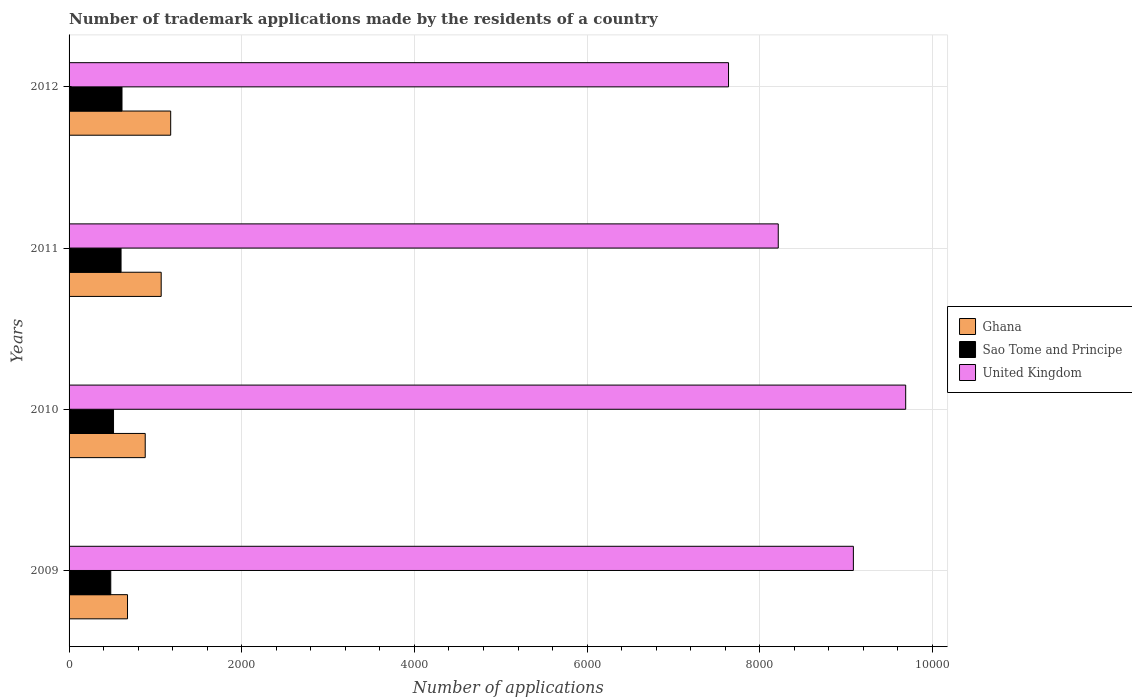How many different coloured bars are there?
Your answer should be very brief. 3. How many groups of bars are there?
Your response must be concise. 4. Are the number of bars on each tick of the Y-axis equal?
Ensure brevity in your answer.  Yes. How many bars are there on the 3rd tick from the top?
Ensure brevity in your answer.  3. What is the number of trademark applications made by the residents in Sao Tome and Principe in 2010?
Ensure brevity in your answer.  515. Across all years, what is the maximum number of trademark applications made by the residents in Ghana?
Make the answer very short. 1177. Across all years, what is the minimum number of trademark applications made by the residents in Sao Tome and Principe?
Provide a succinct answer. 483. In which year was the number of trademark applications made by the residents in United Kingdom minimum?
Offer a terse response. 2012. What is the total number of trademark applications made by the residents in Sao Tome and Principe in the graph?
Keep it short and to the point. 2213. What is the difference between the number of trademark applications made by the residents in Sao Tome and Principe in 2010 and that in 2011?
Ensure brevity in your answer.  -87. What is the difference between the number of trademark applications made by the residents in United Kingdom in 2009 and the number of trademark applications made by the residents in Ghana in 2012?
Offer a very short reply. 7907. What is the average number of trademark applications made by the residents in Ghana per year?
Make the answer very short. 950.75. In the year 2010, what is the difference between the number of trademark applications made by the residents in United Kingdom and number of trademark applications made by the residents in Ghana?
Your answer should be compact. 8808. What is the ratio of the number of trademark applications made by the residents in Ghana in 2011 to that in 2012?
Provide a succinct answer. 0.91. Is the number of trademark applications made by the residents in Ghana in 2011 less than that in 2012?
Offer a terse response. Yes. Is the difference between the number of trademark applications made by the residents in United Kingdom in 2009 and 2012 greater than the difference between the number of trademark applications made by the residents in Ghana in 2009 and 2012?
Ensure brevity in your answer.  Yes. What is the difference between the highest and the lowest number of trademark applications made by the residents in Sao Tome and Principe?
Ensure brevity in your answer.  130. In how many years, is the number of trademark applications made by the residents in Sao Tome and Principe greater than the average number of trademark applications made by the residents in Sao Tome and Principe taken over all years?
Give a very brief answer. 2. Is the sum of the number of trademark applications made by the residents in United Kingdom in 2011 and 2012 greater than the maximum number of trademark applications made by the residents in Ghana across all years?
Keep it short and to the point. Yes. What does the 1st bar from the top in 2010 represents?
Provide a succinct answer. United Kingdom. What does the 1st bar from the bottom in 2009 represents?
Keep it short and to the point. Ghana. Is it the case that in every year, the sum of the number of trademark applications made by the residents in Ghana and number of trademark applications made by the residents in Sao Tome and Principe is greater than the number of trademark applications made by the residents in United Kingdom?
Ensure brevity in your answer.  No. How many bars are there?
Provide a short and direct response. 12. How many years are there in the graph?
Your answer should be very brief. 4. What is the difference between two consecutive major ticks on the X-axis?
Ensure brevity in your answer.  2000. How are the legend labels stacked?
Your answer should be very brief. Vertical. What is the title of the graph?
Provide a succinct answer. Number of trademark applications made by the residents of a country. Does "Turkey" appear as one of the legend labels in the graph?
Your answer should be very brief. No. What is the label or title of the X-axis?
Make the answer very short. Number of applications. What is the Number of applications in Ghana in 2009?
Keep it short and to the point. 677. What is the Number of applications in Sao Tome and Principe in 2009?
Provide a succinct answer. 483. What is the Number of applications in United Kingdom in 2009?
Your response must be concise. 9084. What is the Number of applications of Ghana in 2010?
Offer a very short reply. 882. What is the Number of applications of Sao Tome and Principe in 2010?
Provide a short and direct response. 515. What is the Number of applications of United Kingdom in 2010?
Keep it short and to the point. 9690. What is the Number of applications in Ghana in 2011?
Ensure brevity in your answer.  1067. What is the Number of applications in Sao Tome and Principe in 2011?
Offer a terse response. 602. What is the Number of applications in United Kingdom in 2011?
Your response must be concise. 8214. What is the Number of applications in Ghana in 2012?
Give a very brief answer. 1177. What is the Number of applications of Sao Tome and Principe in 2012?
Keep it short and to the point. 613. What is the Number of applications of United Kingdom in 2012?
Offer a terse response. 7638. Across all years, what is the maximum Number of applications in Ghana?
Keep it short and to the point. 1177. Across all years, what is the maximum Number of applications of Sao Tome and Principe?
Give a very brief answer. 613. Across all years, what is the maximum Number of applications in United Kingdom?
Give a very brief answer. 9690. Across all years, what is the minimum Number of applications of Ghana?
Provide a short and direct response. 677. Across all years, what is the minimum Number of applications of Sao Tome and Principe?
Provide a succinct answer. 483. Across all years, what is the minimum Number of applications in United Kingdom?
Make the answer very short. 7638. What is the total Number of applications of Ghana in the graph?
Your answer should be compact. 3803. What is the total Number of applications of Sao Tome and Principe in the graph?
Provide a short and direct response. 2213. What is the total Number of applications of United Kingdom in the graph?
Provide a succinct answer. 3.46e+04. What is the difference between the Number of applications of Ghana in 2009 and that in 2010?
Keep it short and to the point. -205. What is the difference between the Number of applications in Sao Tome and Principe in 2009 and that in 2010?
Keep it short and to the point. -32. What is the difference between the Number of applications in United Kingdom in 2009 and that in 2010?
Make the answer very short. -606. What is the difference between the Number of applications of Ghana in 2009 and that in 2011?
Provide a succinct answer. -390. What is the difference between the Number of applications in Sao Tome and Principe in 2009 and that in 2011?
Keep it short and to the point. -119. What is the difference between the Number of applications in United Kingdom in 2009 and that in 2011?
Your response must be concise. 870. What is the difference between the Number of applications in Ghana in 2009 and that in 2012?
Your answer should be very brief. -500. What is the difference between the Number of applications in Sao Tome and Principe in 2009 and that in 2012?
Give a very brief answer. -130. What is the difference between the Number of applications in United Kingdom in 2009 and that in 2012?
Your answer should be compact. 1446. What is the difference between the Number of applications of Ghana in 2010 and that in 2011?
Your answer should be very brief. -185. What is the difference between the Number of applications of Sao Tome and Principe in 2010 and that in 2011?
Offer a very short reply. -87. What is the difference between the Number of applications of United Kingdom in 2010 and that in 2011?
Provide a succinct answer. 1476. What is the difference between the Number of applications in Ghana in 2010 and that in 2012?
Offer a very short reply. -295. What is the difference between the Number of applications in Sao Tome and Principe in 2010 and that in 2012?
Make the answer very short. -98. What is the difference between the Number of applications in United Kingdom in 2010 and that in 2012?
Give a very brief answer. 2052. What is the difference between the Number of applications in Ghana in 2011 and that in 2012?
Give a very brief answer. -110. What is the difference between the Number of applications in United Kingdom in 2011 and that in 2012?
Provide a short and direct response. 576. What is the difference between the Number of applications in Ghana in 2009 and the Number of applications in Sao Tome and Principe in 2010?
Keep it short and to the point. 162. What is the difference between the Number of applications in Ghana in 2009 and the Number of applications in United Kingdom in 2010?
Offer a very short reply. -9013. What is the difference between the Number of applications of Sao Tome and Principe in 2009 and the Number of applications of United Kingdom in 2010?
Offer a very short reply. -9207. What is the difference between the Number of applications in Ghana in 2009 and the Number of applications in Sao Tome and Principe in 2011?
Provide a succinct answer. 75. What is the difference between the Number of applications of Ghana in 2009 and the Number of applications of United Kingdom in 2011?
Give a very brief answer. -7537. What is the difference between the Number of applications in Sao Tome and Principe in 2009 and the Number of applications in United Kingdom in 2011?
Your answer should be very brief. -7731. What is the difference between the Number of applications of Ghana in 2009 and the Number of applications of Sao Tome and Principe in 2012?
Offer a terse response. 64. What is the difference between the Number of applications in Ghana in 2009 and the Number of applications in United Kingdom in 2012?
Make the answer very short. -6961. What is the difference between the Number of applications in Sao Tome and Principe in 2009 and the Number of applications in United Kingdom in 2012?
Your response must be concise. -7155. What is the difference between the Number of applications in Ghana in 2010 and the Number of applications in Sao Tome and Principe in 2011?
Ensure brevity in your answer.  280. What is the difference between the Number of applications in Ghana in 2010 and the Number of applications in United Kingdom in 2011?
Give a very brief answer. -7332. What is the difference between the Number of applications of Sao Tome and Principe in 2010 and the Number of applications of United Kingdom in 2011?
Your answer should be very brief. -7699. What is the difference between the Number of applications in Ghana in 2010 and the Number of applications in Sao Tome and Principe in 2012?
Ensure brevity in your answer.  269. What is the difference between the Number of applications of Ghana in 2010 and the Number of applications of United Kingdom in 2012?
Make the answer very short. -6756. What is the difference between the Number of applications of Sao Tome and Principe in 2010 and the Number of applications of United Kingdom in 2012?
Keep it short and to the point. -7123. What is the difference between the Number of applications of Ghana in 2011 and the Number of applications of Sao Tome and Principe in 2012?
Your answer should be very brief. 454. What is the difference between the Number of applications of Ghana in 2011 and the Number of applications of United Kingdom in 2012?
Make the answer very short. -6571. What is the difference between the Number of applications in Sao Tome and Principe in 2011 and the Number of applications in United Kingdom in 2012?
Your response must be concise. -7036. What is the average Number of applications in Ghana per year?
Give a very brief answer. 950.75. What is the average Number of applications of Sao Tome and Principe per year?
Keep it short and to the point. 553.25. What is the average Number of applications of United Kingdom per year?
Make the answer very short. 8656.5. In the year 2009, what is the difference between the Number of applications of Ghana and Number of applications of Sao Tome and Principe?
Keep it short and to the point. 194. In the year 2009, what is the difference between the Number of applications of Ghana and Number of applications of United Kingdom?
Offer a very short reply. -8407. In the year 2009, what is the difference between the Number of applications in Sao Tome and Principe and Number of applications in United Kingdom?
Your response must be concise. -8601. In the year 2010, what is the difference between the Number of applications in Ghana and Number of applications in Sao Tome and Principe?
Your answer should be compact. 367. In the year 2010, what is the difference between the Number of applications of Ghana and Number of applications of United Kingdom?
Give a very brief answer. -8808. In the year 2010, what is the difference between the Number of applications of Sao Tome and Principe and Number of applications of United Kingdom?
Offer a terse response. -9175. In the year 2011, what is the difference between the Number of applications in Ghana and Number of applications in Sao Tome and Principe?
Offer a very short reply. 465. In the year 2011, what is the difference between the Number of applications of Ghana and Number of applications of United Kingdom?
Your answer should be compact. -7147. In the year 2011, what is the difference between the Number of applications of Sao Tome and Principe and Number of applications of United Kingdom?
Your answer should be very brief. -7612. In the year 2012, what is the difference between the Number of applications in Ghana and Number of applications in Sao Tome and Principe?
Offer a terse response. 564. In the year 2012, what is the difference between the Number of applications in Ghana and Number of applications in United Kingdom?
Provide a short and direct response. -6461. In the year 2012, what is the difference between the Number of applications of Sao Tome and Principe and Number of applications of United Kingdom?
Keep it short and to the point. -7025. What is the ratio of the Number of applications of Ghana in 2009 to that in 2010?
Your answer should be very brief. 0.77. What is the ratio of the Number of applications in Sao Tome and Principe in 2009 to that in 2010?
Offer a terse response. 0.94. What is the ratio of the Number of applications of United Kingdom in 2009 to that in 2010?
Provide a succinct answer. 0.94. What is the ratio of the Number of applications of Ghana in 2009 to that in 2011?
Keep it short and to the point. 0.63. What is the ratio of the Number of applications of Sao Tome and Principe in 2009 to that in 2011?
Give a very brief answer. 0.8. What is the ratio of the Number of applications of United Kingdom in 2009 to that in 2011?
Provide a short and direct response. 1.11. What is the ratio of the Number of applications in Ghana in 2009 to that in 2012?
Offer a terse response. 0.58. What is the ratio of the Number of applications in Sao Tome and Principe in 2009 to that in 2012?
Provide a short and direct response. 0.79. What is the ratio of the Number of applications in United Kingdom in 2009 to that in 2012?
Give a very brief answer. 1.19. What is the ratio of the Number of applications in Ghana in 2010 to that in 2011?
Your answer should be very brief. 0.83. What is the ratio of the Number of applications of Sao Tome and Principe in 2010 to that in 2011?
Provide a short and direct response. 0.86. What is the ratio of the Number of applications of United Kingdom in 2010 to that in 2011?
Your response must be concise. 1.18. What is the ratio of the Number of applications of Ghana in 2010 to that in 2012?
Provide a short and direct response. 0.75. What is the ratio of the Number of applications in Sao Tome and Principe in 2010 to that in 2012?
Give a very brief answer. 0.84. What is the ratio of the Number of applications in United Kingdom in 2010 to that in 2012?
Your answer should be compact. 1.27. What is the ratio of the Number of applications of Ghana in 2011 to that in 2012?
Ensure brevity in your answer.  0.91. What is the ratio of the Number of applications of Sao Tome and Principe in 2011 to that in 2012?
Your answer should be very brief. 0.98. What is the ratio of the Number of applications in United Kingdom in 2011 to that in 2012?
Provide a succinct answer. 1.08. What is the difference between the highest and the second highest Number of applications in Ghana?
Keep it short and to the point. 110. What is the difference between the highest and the second highest Number of applications of United Kingdom?
Offer a very short reply. 606. What is the difference between the highest and the lowest Number of applications of Sao Tome and Principe?
Ensure brevity in your answer.  130. What is the difference between the highest and the lowest Number of applications in United Kingdom?
Provide a short and direct response. 2052. 